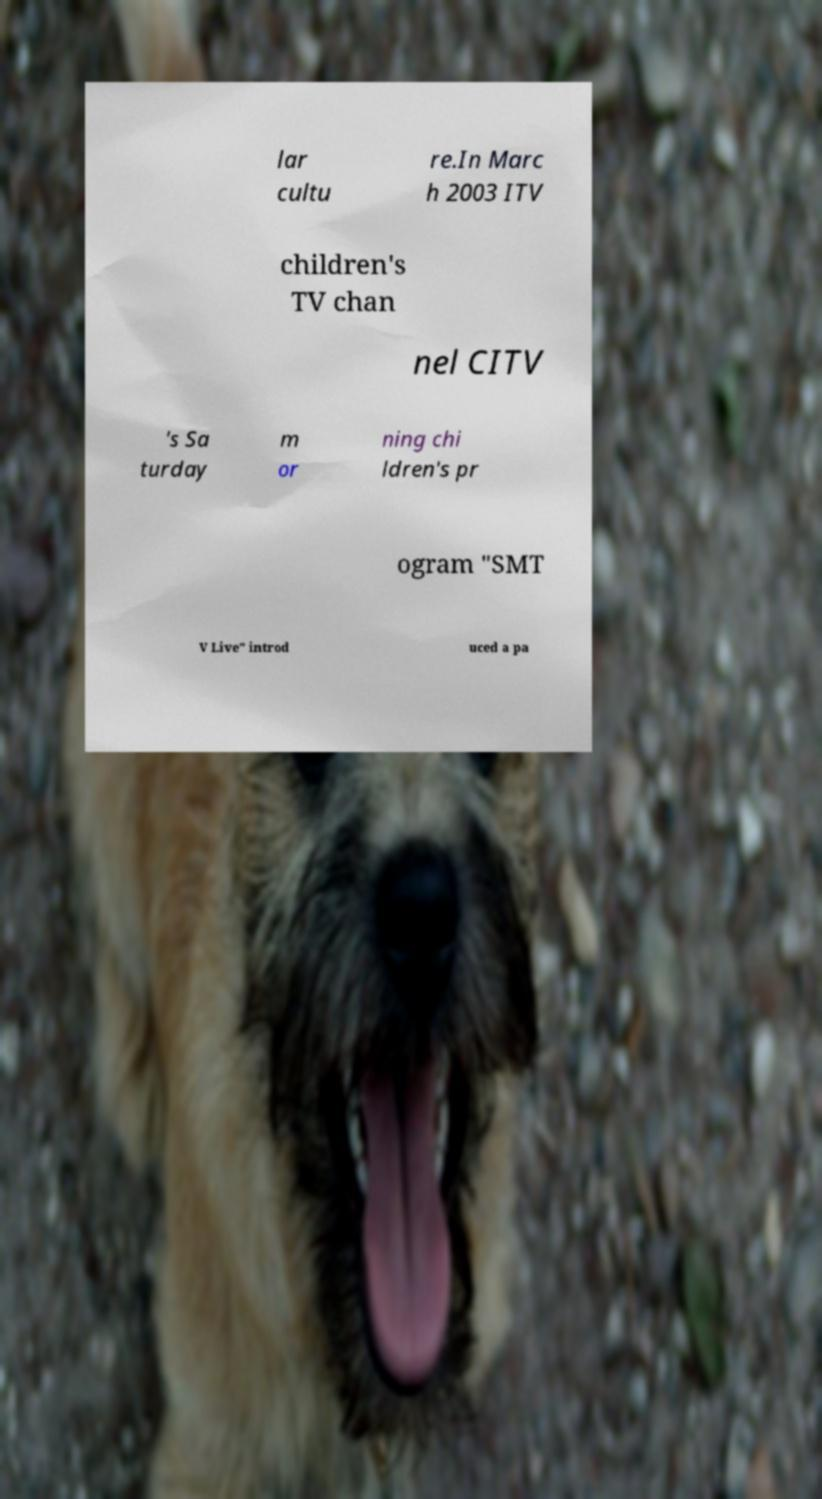I need the written content from this picture converted into text. Can you do that? lar cultu re.In Marc h 2003 ITV children's TV chan nel CITV 's Sa turday m or ning chi ldren's pr ogram "SMT V Live" introd uced a pa 